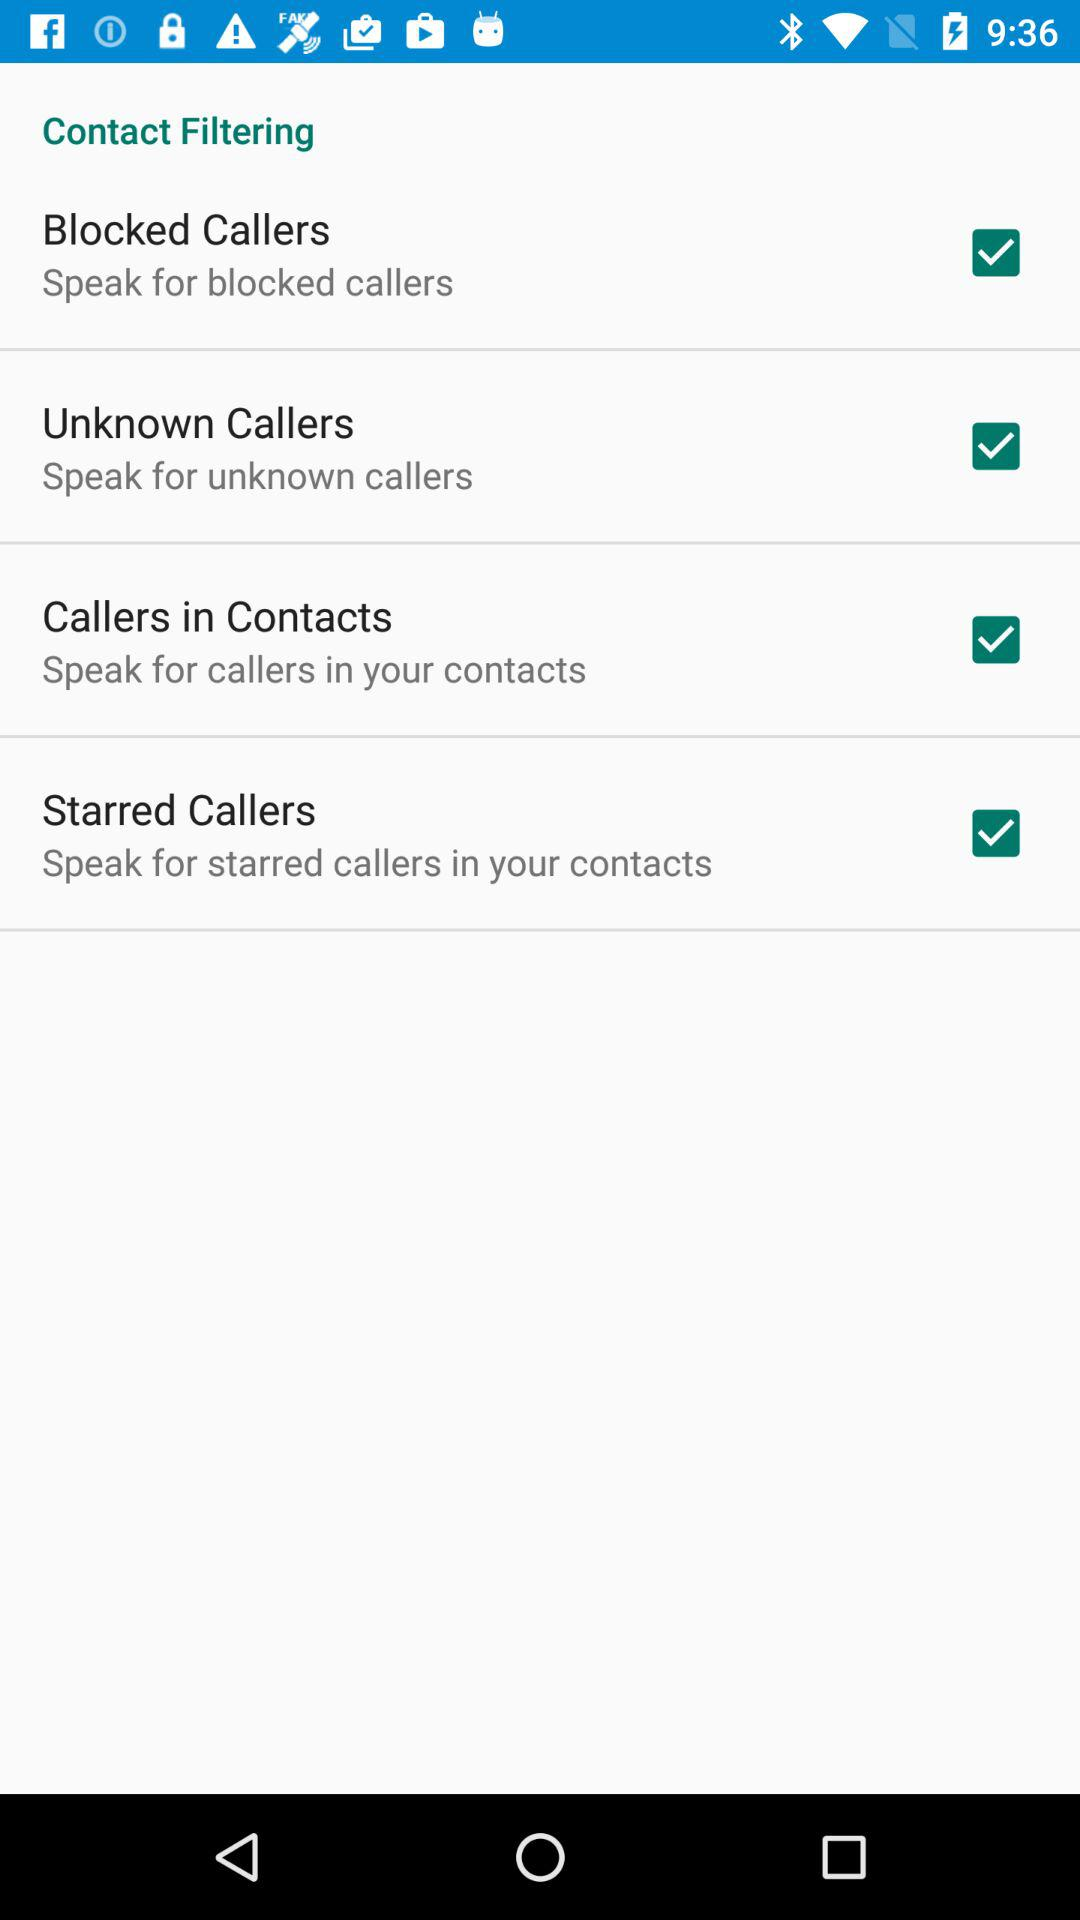What is the setting for "Unknown Callers"? The setting for "Unknown Callers" is "Speak for unknown callers". 